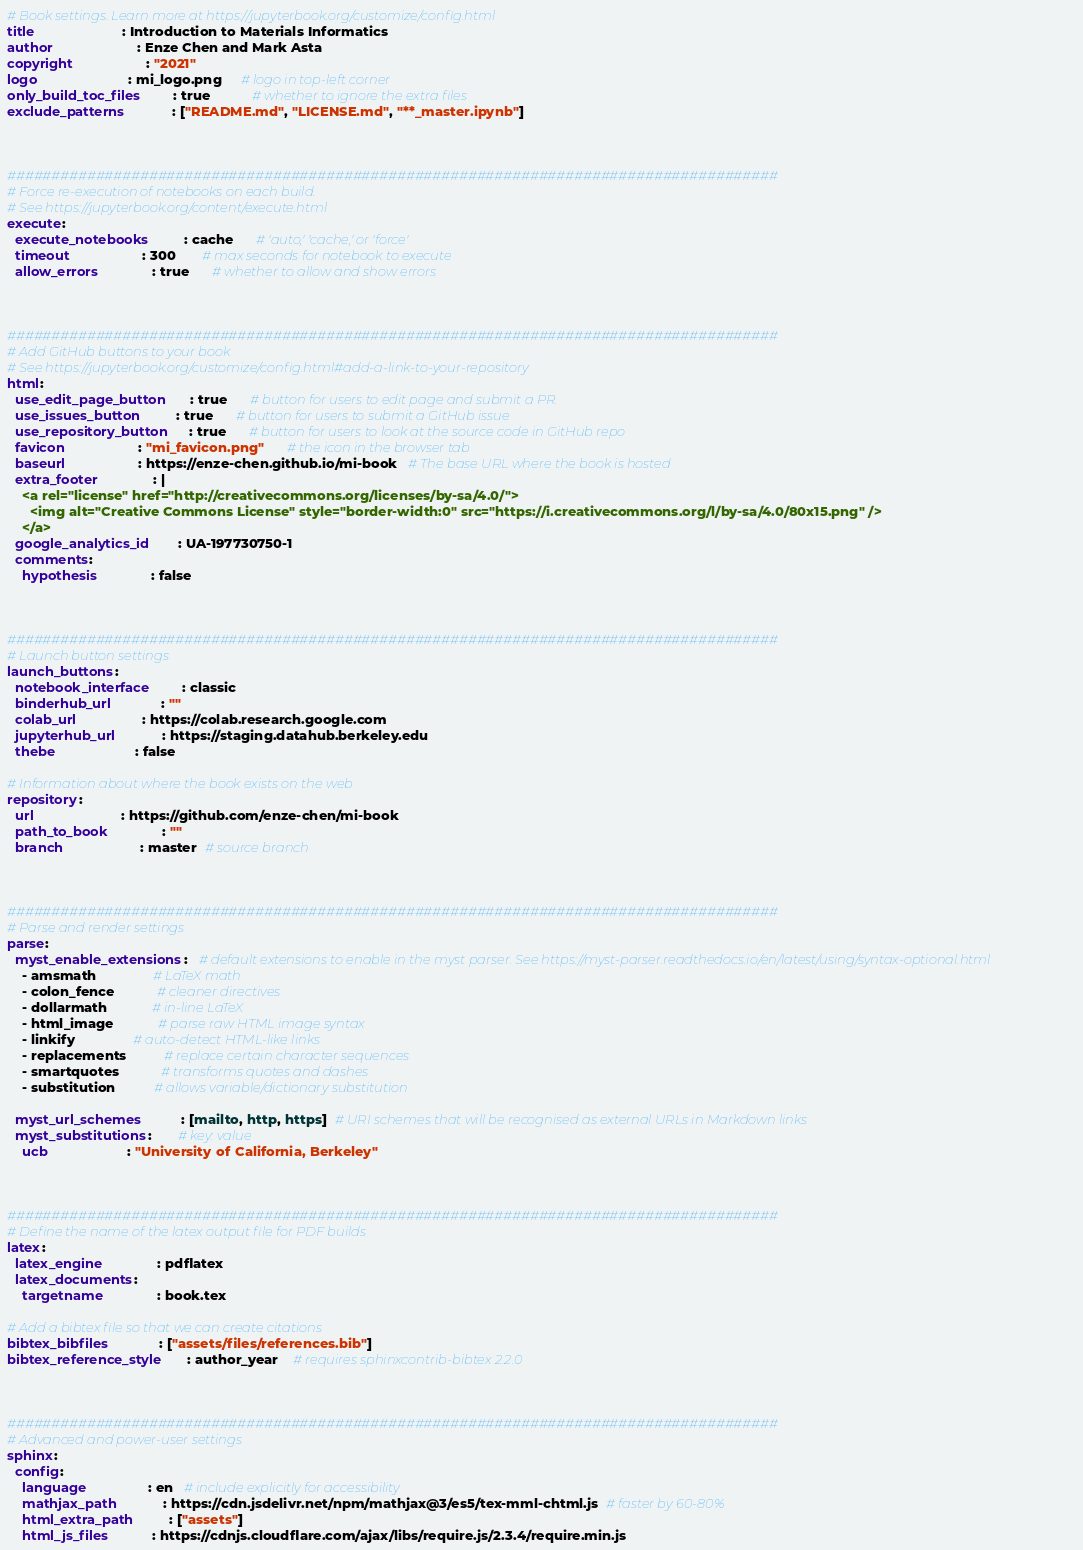Convert code to text. <code><loc_0><loc_0><loc_500><loc_500><_YAML_># Book settings. Learn more at https://jupyterbook.org/customize/config.html
title                       : Introduction to Materials Informatics
author                      : Enze Chen and Mark Asta
copyright                   : "2021"
logo                        : mi_logo.png     # logo in top-left corner
only_build_toc_files        : true           # whether to ignore the extra files
exclude_patterns            : ["README.md", "LICENSE.md", "**_master.ipynb"]



#######################################################################################
# Force re-execution of notebooks on each build.
# See https://jupyterbook.org/content/execute.html
execute:
  execute_notebooks         : cache      # 'auto,' 'cache,' or 'force'
  timeout                   : 300       # max seconds for notebook to execute
  allow_errors              : true      # whether to allow and show errors



#######################################################################################
# Add GitHub buttons to your book
# See https://jupyterbook.org/customize/config.html#add-a-link-to-your-repository
html:
  use_edit_page_button      : true      # button for users to edit page and submit a PR.
  use_issues_button         : true      # button for users to submit a GitHub issue
  use_repository_button     : true      # button for users to look at the source code in GitHub repo
  favicon                   : "mi_favicon.png"      # the icon in the browser tab
  baseurl                   : https://enze-chen.github.io/mi-book   # The base URL where the book is hosted
  extra_footer              : |
    <a rel="license" href="http://creativecommons.org/licenses/by-sa/4.0/">
      <img alt="Creative Commons License" style="border-width:0" src="https://i.creativecommons.org/l/by-sa/4.0/80x15.png" />
    </a>
  google_analytics_id       : UA-197730750-1
  comments:
    hypothesis              : false



#######################################################################################
# Launch button settings
launch_buttons:
  notebook_interface        : classic
  binderhub_url             : ""
  colab_url                 : https://colab.research.google.com
  jupyterhub_url            : https://staging.datahub.berkeley.edu
  thebe                     : false

# Information about where the book exists on the web
repository:
  url                       : https://github.com/enze-chen/mi-book 
  path_to_book              : ""
  branch                    : master  # source branch



#######################################################################################
# Parse and render settings
parse:
  myst_enable_extensions:   # default extensions to enable in the myst parser. See https://myst-parser.readthedocs.io/en/latest/using/syntax-optional.html
    - amsmath               # LaTeX math
    - colon_fence           # cleaner directives
    - dollarmath            # in-line LaTeX
    - html_image            # parse raw HTML image syntax
    - linkify               # auto-detect HTML-like links
    - replacements          # replace certain character sequences
    - smartquotes           # transforms quotes and dashes
    - substitution          # allows variable/dictionary substitution

  myst_url_schemes          : [mailto, http, https]  # URI schemes that will be recognised as external URLs in Markdown links
  myst_substitutions:       # key: value
    ucb                     : "University of California, Berkeley"



#######################################################################################
# Define the name of the latex output file for PDF builds
latex:
  latex_engine              : pdflatex
  latex_documents:
    targetname              : book.tex

# Add a bibtex file so that we can create citations
bibtex_bibfiles             : ["assets/files/references.bib"]
bibtex_reference_style      : author_year    # requires sphinxcontrib-bibtex 2.2.0



#######################################################################################
# Advanced and power-user settings
sphinx:
  config:
    language                : en   # include explicitly for accessibility
    mathjax_path            : https://cdn.jsdelivr.net/npm/mathjax@3/es5/tex-mml-chtml.js  # faster by 60-80%
    html_extra_path         : ["assets"]
    html_js_files           : https://cdnjs.cloudflare.com/ajax/libs/require.js/2.3.4/require.min.js
</code> 